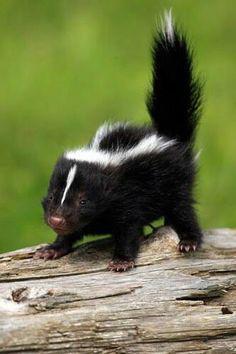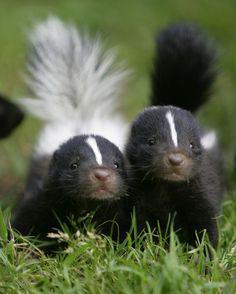The first image is the image on the left, the second image is the image on the right. Assess this claim about the two images: "Left and right images do not contain the same number of skunks, and the left image contains at least one leftward angled skunk with an upright tail.". Correct or not? Answer yes or no. Yes. The first image is the image on the left, the second image is the image on the right. Examine the images to the left and right. Is the description "Two skunks are visible." accurate? Answer yes or no. No. 